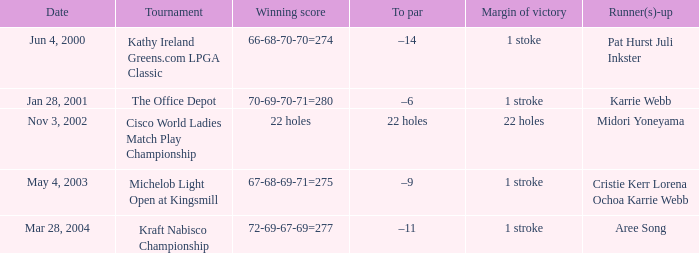Where is the margin of victory dated mar 28, 2004? 1 stroke. Would you mind parsing the complete table? {'header': ['Date', 'Tournament', 'Winning score', 'To par', 'Margin of victory', 'Runner(s)-up'], 'rows': [['Jun 4, 2000', 'Kathy Ireland Greens.com LPGA Classic', '66-68-70-70=274', '–14', '1 stoke', 'Pat Hurst Juli Inkster'], ['Jan 28, 2001', 'The Office Depot', '70-69-70-71=280', '–6', '1 stroke', 'Karrie Webb'], ['Nov 3, 2002', 'Cisco World Ladies Match Play Championship', '22 holes', '22 holes', '22 holes', 'Midori Yoneyama'], ['May 4, 2003', 'Michelob Light Open at Kingsmill', '67-68-69-71=275', '–9', '1 stroke', 'Cristie Kerr Lorena Ochoa Karrie Webb'], ['Mar 28, 2004', 'Kraft Nabisco Championship', '72-69-67-69=277', '–11', '1 stroke', 'Aree Song']]} 